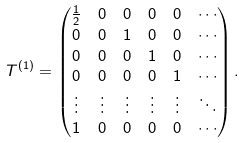<formula> <loc_0><loc_0><loc_500><loc_500>T ^ { ( 1 ) } & = \begin{pmatrix} \frac { 1 } { 2 } & 0 & 0 & 0 & 0 & \cdots \\ 0 & 0 & 1 & 0 & 0 & \cdots \\ 0 & 0 & 0 & 1 & 0 & \cdots \\ 0 & 0 & 0 & 0 & 1 & \cdots \\ \vdots & \vdots & \vdots & \vdots & \vdots & \ddots \\ 1 & 0 & 0 & 0 & 0 & \cdots \end{pmatrix} .</formula> 